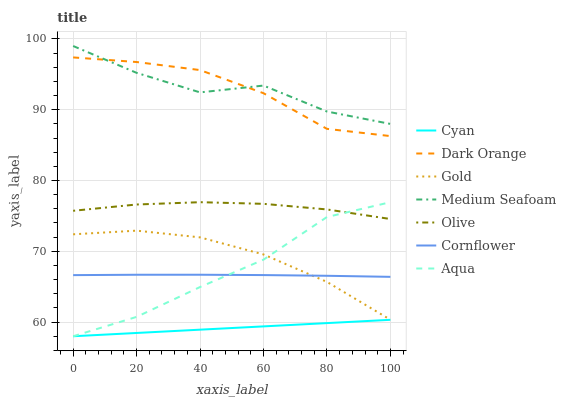Does Gold have the minimum area under the curve?
Answer yes or no. No. Does Gold have the maximum area under the curve?
Answer yes or no. No. Is Gold the smoothest?
Answer yes or no. No. Is Gold the roughest?
Answer yes or no. No. Does Gold have the lowest value?
Answer yes or no. No. Does Gold have the highest value?
Answer yes or no. No. Is Olive less than Dark Orange?
Answer yes or no. Yes. Is Dark Orange greater than Gold?
Answer yes or no. Yes. Does Olive intersect Dark Orange?
Answer yes or no. No. 